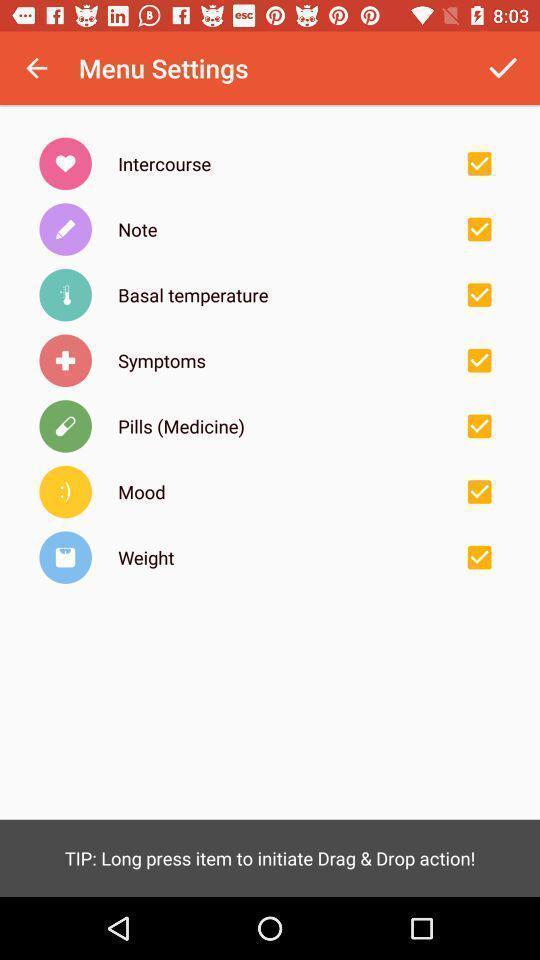What is the overall content of this screenshot? Page showing multiple options on health app. 